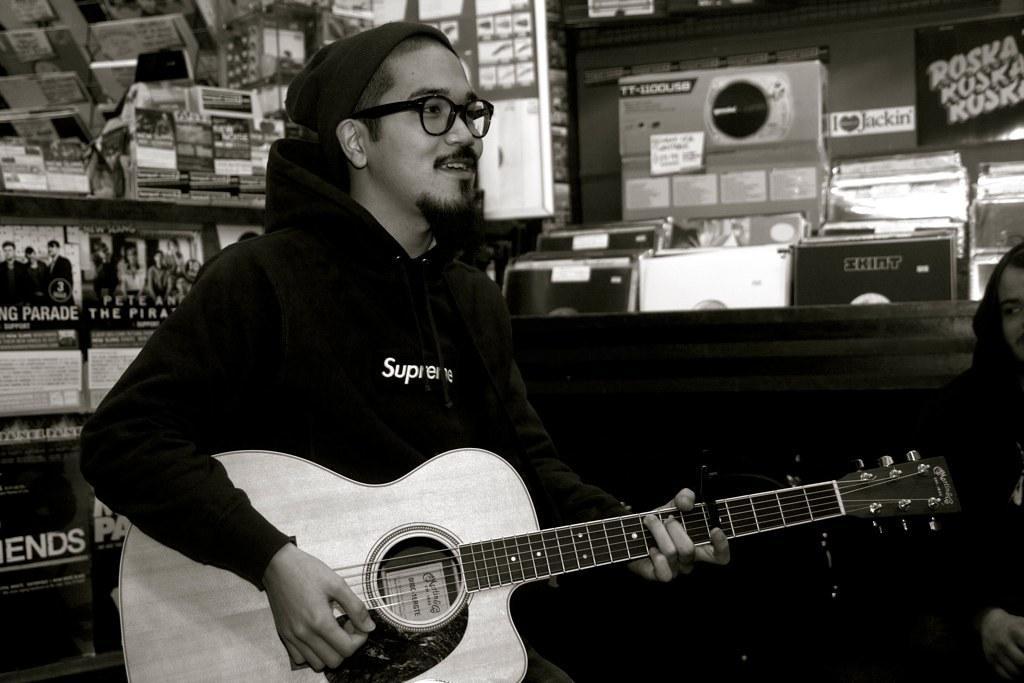Could you give a brief overview of what you see in this image? This person playing guitar and wear cap and glasses,this person sitting. On the background we can see posters,wall. 